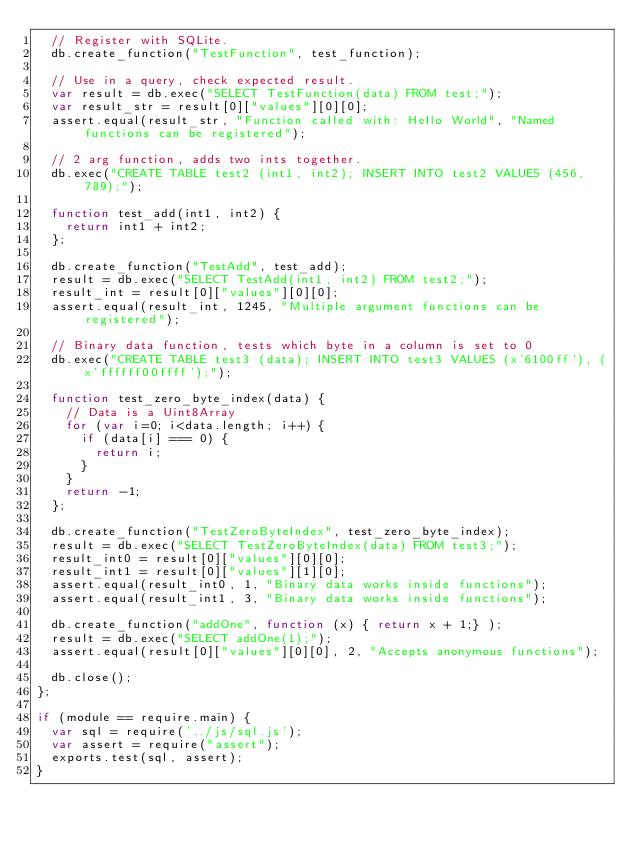<code> <loc_0><loc_0><loc_500><loc_500><_JavaScript_>  // Register with SQLite.
  db.create_function("TestFunction", test_function);

  // Use in a query, check expected result.
  var result = db.exec("SELECT TestFunction(data) FROM test;");
  var result_str = result[0]["values"][0][0];
  assert.equal(result_str, "Function called with: Hello World", "Named functions can be registered");

  // 2 arg function, adds two ints together.
  db.exec("CREATE TABLE test2 (int1, int2); INSERT INTO test2 VALUES (456, 789);");

  function test_add(int1, int2) {
    return int1 + int2;
  };

  db.create_function("TestAdd", test_add);
  result = db.exec("SELECT TestAdd(int1, int2) FROM test2;");
  result_int = result[0]["values"][0][0];
  assert.equal(result_int, 1245, "Multiple argument functions can be registered");

  // Binary data function, tests which byte in a column is set to 0
  db.exec("CREATE TABLE test3 (data); INSERT INTO test3 VALUES (x'6100ff'), (x'ffffff00ffff');");

  function test_zero_byte_index(data) {
    // Data is a Uint8Array
    for (var i=0; i<data.length; i++) {
      if (data[i] === 0) {
        return i;
      }
    }
    return -1;
  };

  db.create_function("TestZeroByteIndex", test_zero_byte_index);
  result = db.exec("SELECT TestZeroByteIndex(data) FROM test3;");
  result_int0 = result[0]["values"][0][0];
  result_int1 = result[0]["values"][1][0];
  assert.equal(result_int0, 1, "Binary data works inside functions");
  assert.equal(result_int1, 3, "Binary data works inside functions");

  db.create_function("addOne", function (x) { return x + 1;} );
  result = db.exec("SELECT addOne(1);");
  assert.equal(result[0]["values"][0][0], 2, "Accepts anonymous functions");

  db.close();
};

if (module == require.main) {
  var sql = require('../js/sql.js');
  var assert = require("assert");
  exports.test(sql, assert);
}
</code> 